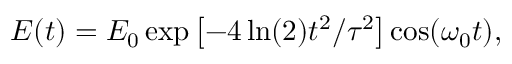Convert formula to latex. <formula><loc_0><loc_0><loc_500><loc_500>E ( t ) = E _ { 0 } \exp \left [ - 4 \ln ( 2 ) t ^ { 2 } / \tau ^ { 2 } \right ] \cos ( \omega _ { 0 } t ) ,</formula> 